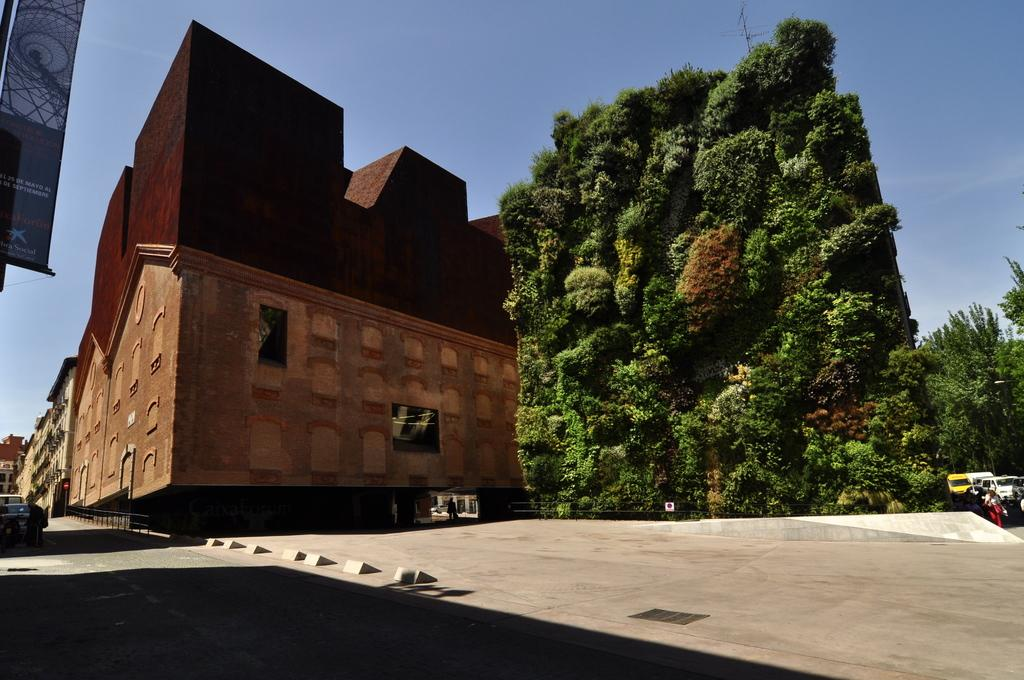What type of structure is present in the image? There is a building in the image. What other natural elements can be seen in the image? There are trees in the image. Are there any man-made objects visible besides the building? Yes, there are vehicles in the image. What is visible at the top of the image? The sky is visible at the top of the image. Can you tell me the name of the lawyer who is arguing a case in the image? There is no lawyer or courtroom scene present in the image; it features a building, trees, vehicles, and the sky. What type of acoustics can be heard in the image? There is no sound or audio present in the image, so it is not possible to determine the acoustics. 